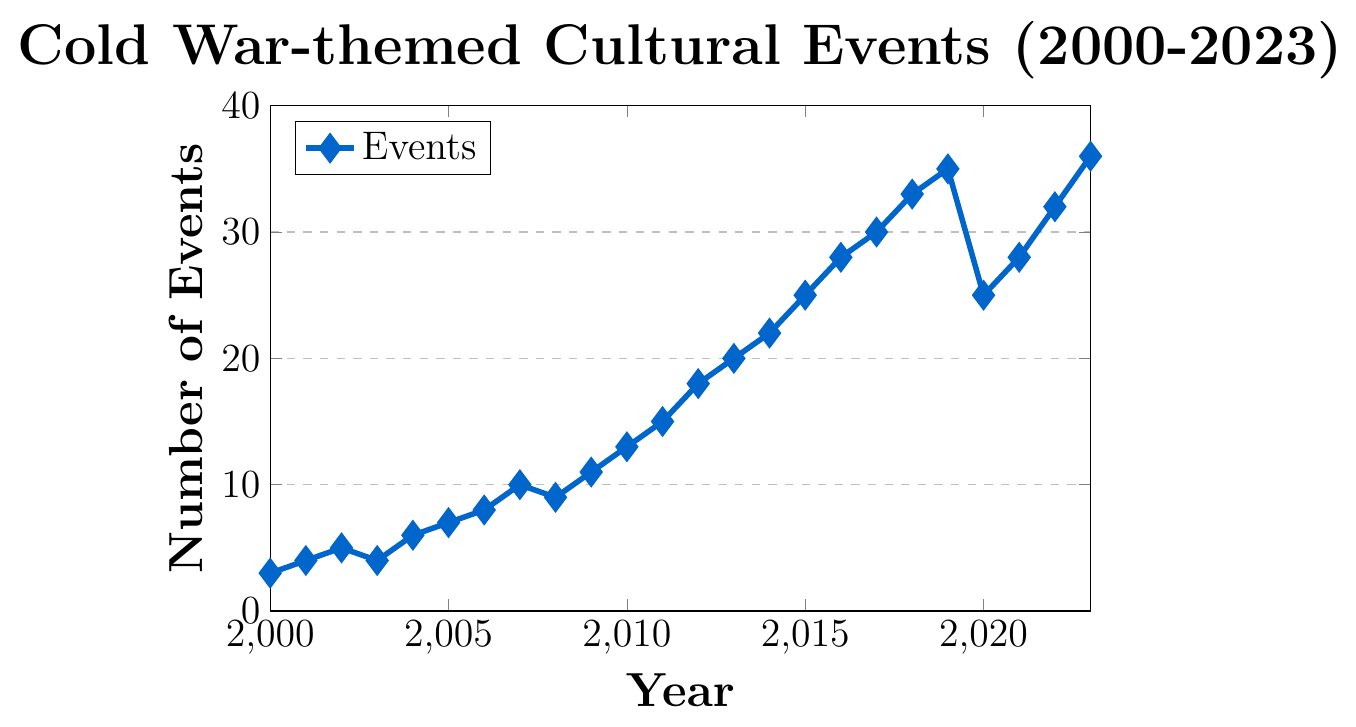What year had the highest number of Cold War-themed events? The highest number value on the y-axis (36) corresponds to the year 2023 on the x-axis.
Answer: 2023 How did the number of events change between 2019 and 2020? In 2019, there were 35 events, and in 2020, there were 25 events. The change is calculated as 35 - 25 = 10.
Answer: Decreased by 10 What is the average number of Cold War-themed events per year from 2000 to 2005? The data points for these years are 3, 4, 5, 4, 6, 7. Sum these up to get 3 + 4 + 5 + 4 + 6 + 7 = 29. The average is then 29 / 6 = 4.83.
Answer: 4.83 In which year did the number of events first reach double digits? Look at the y-axis values; the first time they reach 10 is at the year 2007.
Answer: 2007 During which period did the number of events increase the fastest? Calculate the differences between consecutive years. The most significant single year increase is from 2018 to 2019 (33 to 35, an increase of 2). For longer periods, from 2012 (18 events) to 2015 (25 events), the increase is 25 - 18 = 7.
Answer: 2012 to 2015 How many years had fewer than 10 Cold War-themed events? Identify the years where the y-values are below 10: 2000, 2001, 2002, 2003, 2004, 2005, 2006.
Answer: 7 years Which years saw a decrease in the number of events from the previous year? Compare event numbers year-over-year: 2003 (4) from 2002 (5), 2008 (9) from 2007 (10), and 2020 (25) from 2019 (35).
Answer: 2003, 2008, 2020 What is the median number of Cold War-themed events from 2000 to 2023? List the event counts: 3, 4, 4, 5, 6, 7, 8, 9, 10, 11, 13, 15, 18, 20, 22, 25, 25, 28, 28, 30, 32, 33, 35, 36. As there are 24 values, the median will be the average of the 12th and 13th values (15 and 18); (15 + 18) / 2 = 16.5.
Answer: 16.5 